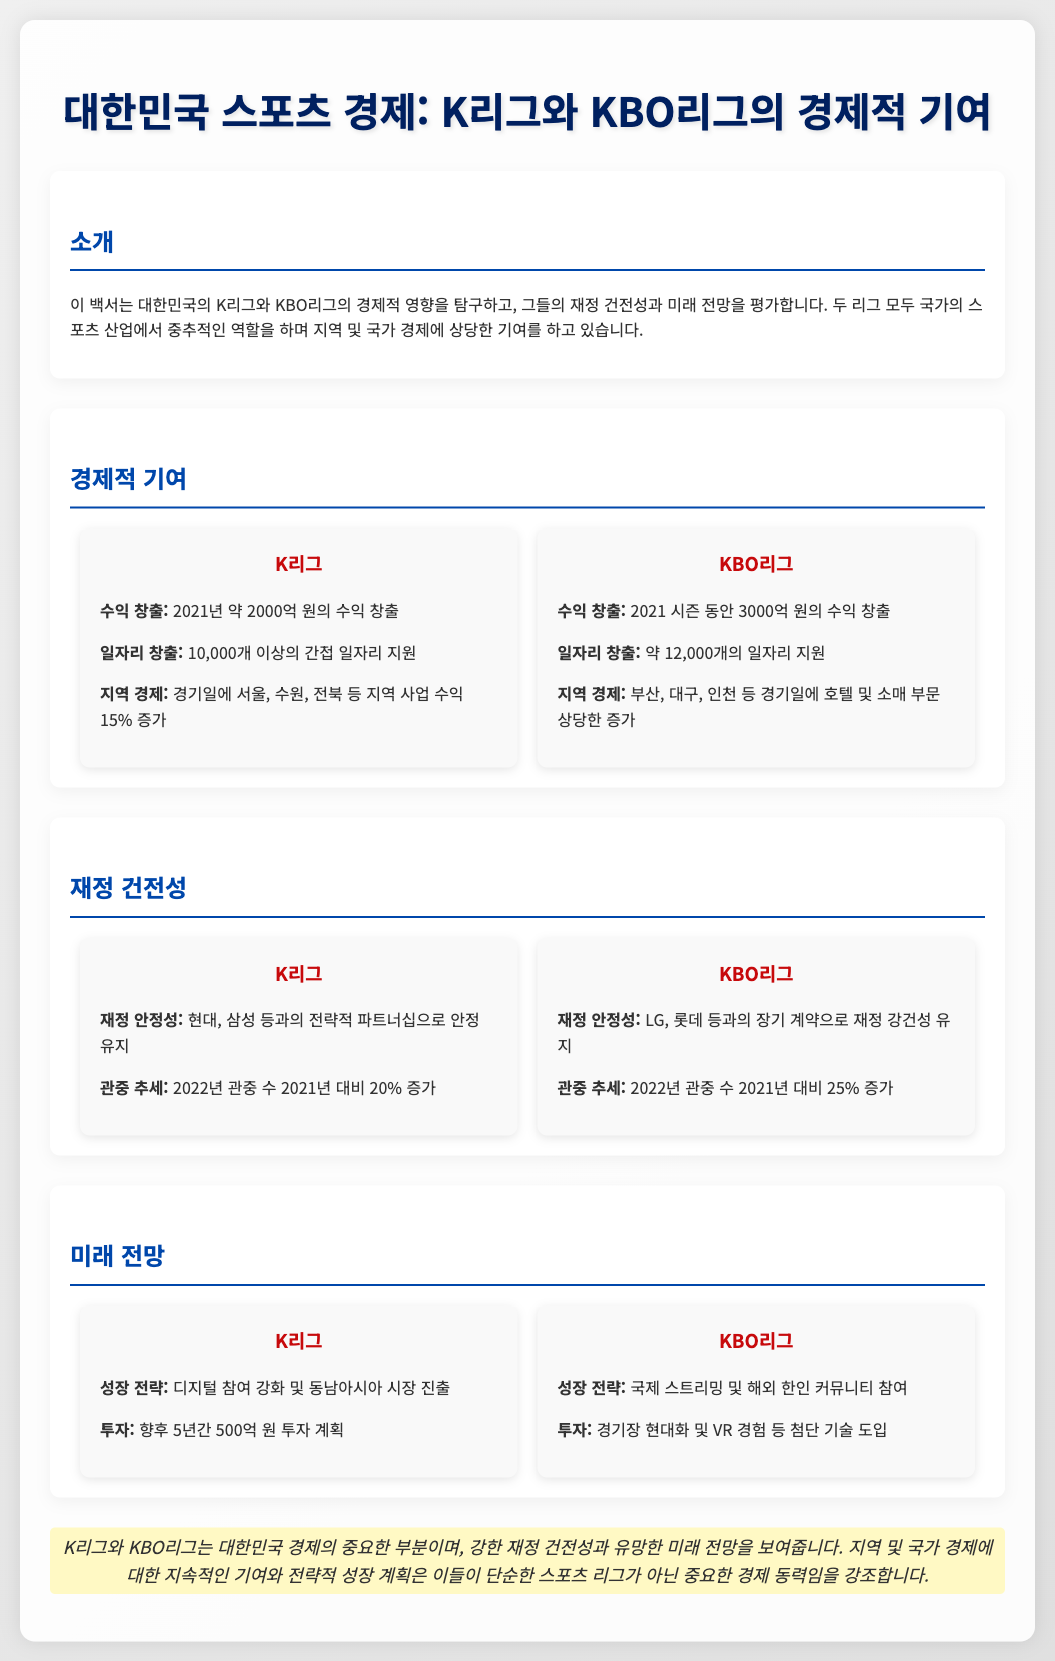What is the total revenue generated by the K-League? The total revenue generated by the K-League in 2021 is mentioned in the document.
Answer: 2000억 원 What is the revenue of the KBO League in 2021? The revenue of the KBO League for the 2021 season is specified in the document.
Answer: 3000억 원 How many indirect jobs does the K-League support? The document indicates the number of indirect jobs supported by the K-League.
Answer: 10,000개 이상 What is the percentage increase in audience for the K-League in 2022? The document states the percentage increase in audience for the K-League compared to 2021.
Answer: 20% What are the growth strategies for the KBO League? The document outlines the growth strategies for the KBO League.
Answer: 국제 스트리밍 및 해외 한인 커뮤니티 참여 How much investment is planned for the K-League over the next five years? The document specifies the investment amount planned for the K-League in the upcoming years.
Answer: 500억 원 What is a significant regional economic contribution of the KBO League? The document highlights the contribution of the KBO League to local businesses on game days.
Answer: 호텔 및 소매 부문 상당한 증가 What year had a financial stability increase due to strategic partnerships for the K-League? The document mentions the year when strategic partnerships helped maintain financial stability for the K-League.
Answer: 2022 What is the conclusion about the K-League and KBO League's role in the economy? The document provides a final statement on the role of both leagues in the economy.
Answer: 중요한 경제 동력 